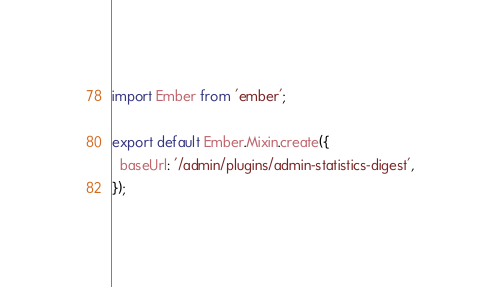<code> <loc_0><loc_0><loc_500><loc_500><_JavaScript_>import Ember from 'ember';

export default Ember.Mixin.create({
  baseUrl: '/admin/plugins/admin-statistics-digest',
});
</code> 